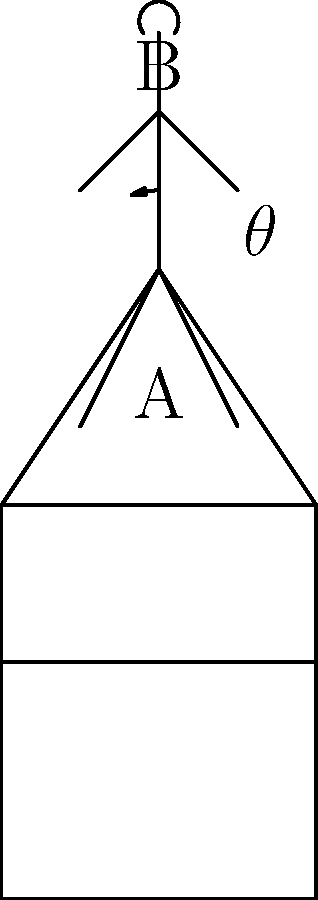In the diagram above, a student is seated in a classroom chair. Point A represents the base of the spine, and point B represents the top of the spine. The angle $\theta$ represents the deviation of the spine from vertical. According to ergonomic standards, what is the maximum recommended value for $\theta$ to maintain proper posture and minimize long-term health issues? To answer this question, we need to consider ergonomic principles for classroom seating:

1. Proper posture is crucial for students' health and comfort during long periods of sitting.

2. The spine should be as close to vertical as possible to minimize stress on the back muscles and vertebrae.

3. However, some flexibility is necessary to accommodate natural body movements and variations in body types.

4. Ergonomic studies have shown that a slight backward tilt of the spine can actually reduce pressure on the intervertebral discs.

5. The generally accepted guideline for maximum spinal tilt in ergonomic seating is 20 degrees from vertical.

6. This 20-degree allowance provides a balance between maintaining near-vertical posture and allowing for some natural curvature of the spine.

7. Angles larger than 20 degrees are associated with increased risk of poor posture habits and potential long-term musculoskeletal issues.

Therefore, the maximum recommended value for $\theta$ according to ergonomic standards is 20 degrees.
Answer: 20 degrees 